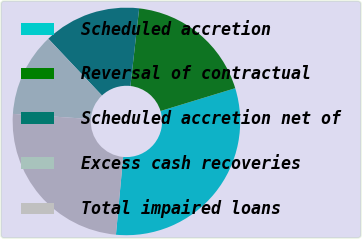Convert chart to OTSL. <chart><loc_0><loc_0><loc_500><loc_500><pie_chart><fcel>Scheduled accretion<fcel>Reversal of contractual<fcel>Scheduled accretion net of<fcel>Excess cash recoveries<fcel>Total impaired loans<nl><fcel>31.19%<fcel>18.5%<fcel>13.83%<fcel>11.9%<fcel>24.59%<nl></chart> 